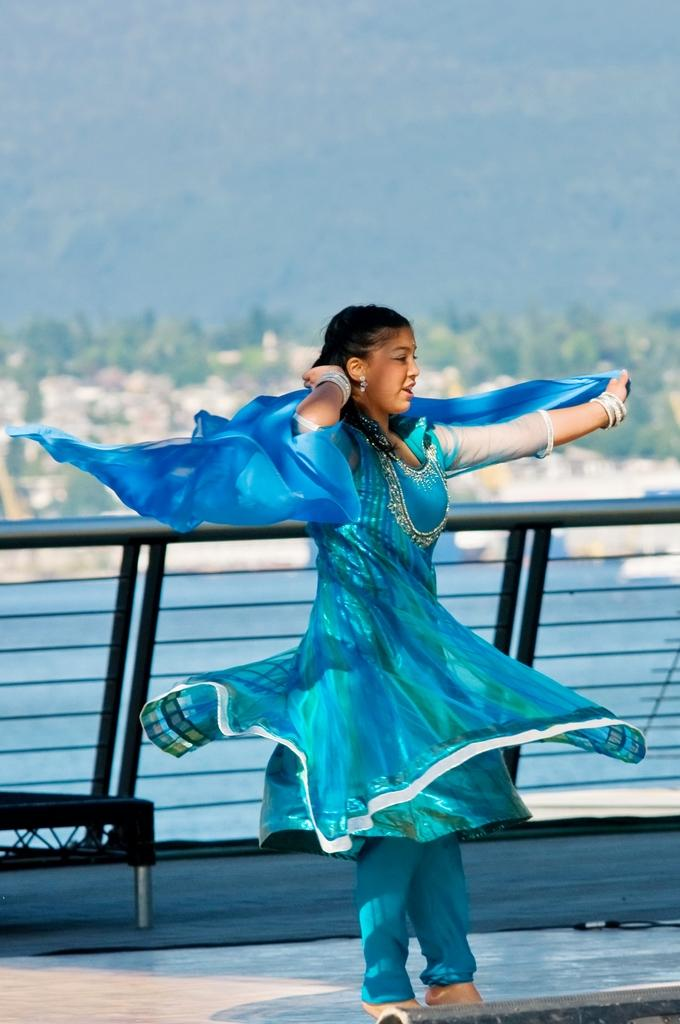What is the person in the image doing? The person is standing near the rail. What can be seen in the background of the image? The background of the image includes water, trees, and the sky. Can you describe the natural setting visible in the image? The natural setting includes water and trees. What type of stocking is the person wearing in the image? There is no information about the person's clothing in the image, so it cannot be determined if they are wearing stockings. 